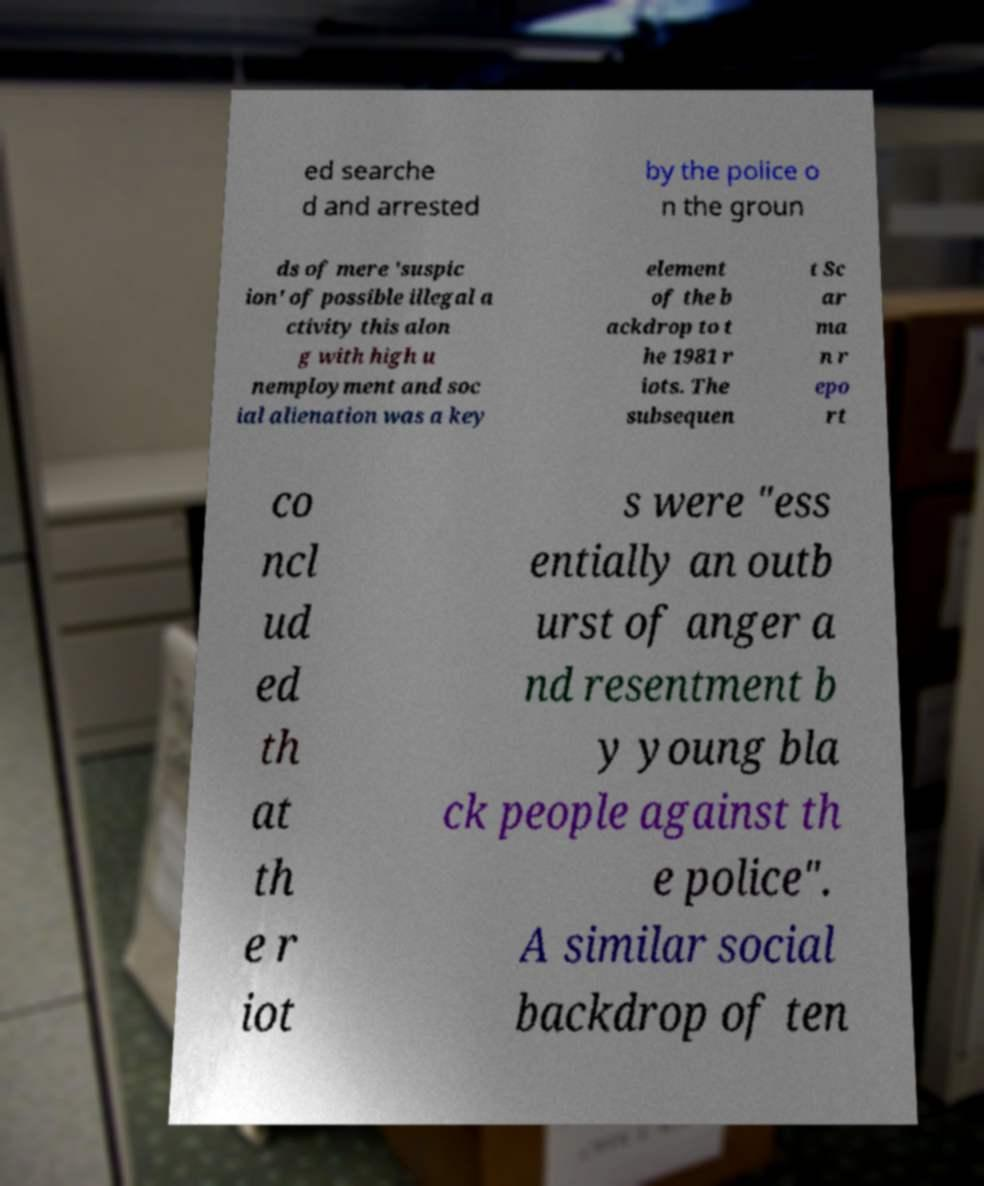Please identify and transcribe the text found in this image. ed searche d and arrested by the police o n the groun ds of mere 'suspic ion' of possible illegal a ctivity this alon g with high u nemployment and soc ial alienation was a key element of the b ackdrop to t he 1981 r iots. The subsequen t Sc ar ma n r epo rt co ncl ud ed th at th e r iot s were "ess entially an outb urst of anger a nd resentment b y young bla ck people against th e police". A similar social backdrop of ten 